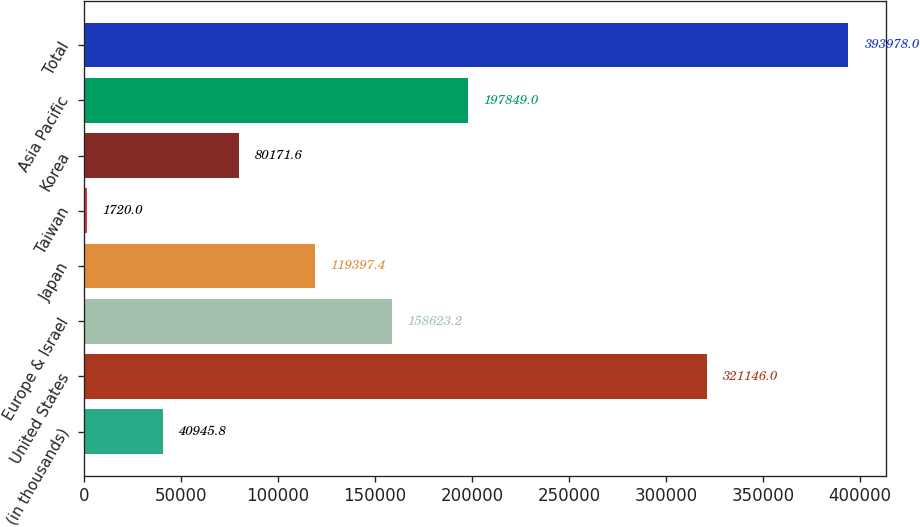Convert chart. <chart><loc_0><loc_0><loc_500><loc_500><bar_chart><fcel>(in thousands)<fcel>United States<fcel>Europe & Israel<fcel>Japan<fcel>Taiwan<fcel>Korea<fcel>Asia Pacific<fcel>Total<nl><fcel>40945.8<fcel>321146<fcel>158623<fcel>119397<fcel>1720<fcel>80171.6<fcel>197849<fcel>393978<nl></chart> 